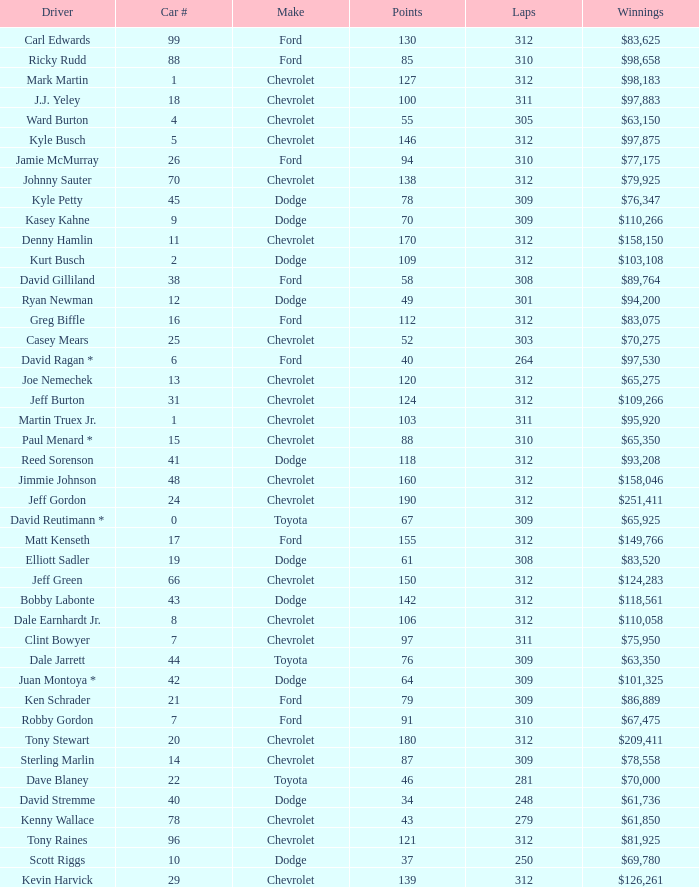What is the lowest number of laps for kyle petty with under 118 points? 309.0. 